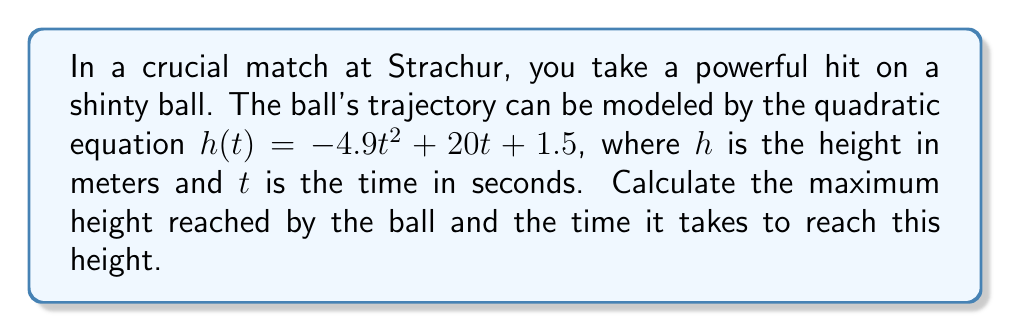Provide a solution to this math problem. To solve this problem, we'll use the properties of quadratic equations and the vertex formula.

1) The general form of a quadratic equation is $f(x) = ax^2 + bx + c$
   In this case, $a = -4.9$, $b = 20$, and $c = 1.5$

2) The vertex of a parabola represents the maximum point for a downward-facing parabola (negative $a$).

3) The x-coordinate of the vertex (which represents the time to reach maximum height) is given by:
   $t = -\frac{b}{2a}$

4) Substituting our values:
   $t = -\frac{20}{2(-4.9)} = \frac{20}{9.8} \approx 2.04$ seconds

5) To find the maximum height, we substitute this t-value back into our original equation:
   $h(2.04) = -4.9(2.04)^2 + 20(2.04) + 1.5$
   $= -4.9(4.1616) + 40.8 + 1.5$
   $= -20.39184 + 40.8 + 1.5$
   $= 21.90816$ meters

6) Rounding to two decimal places, the maximum height is 21.91 meters.
Answer: Maximum height: 21.91 m, Time to reach maximum: 2.04 s 